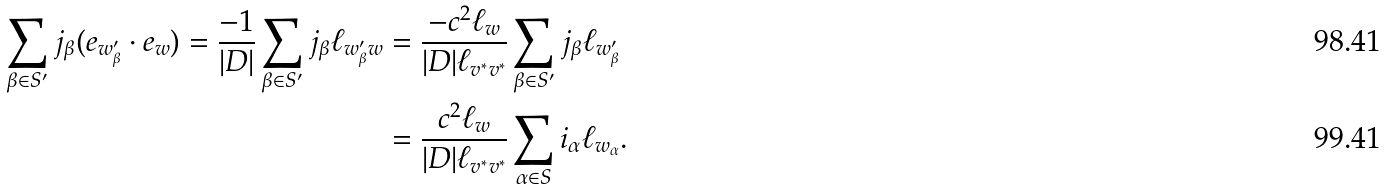<formula> <loc_0><loc_0><loc_500><loc_500>\sum _ { \beta \in S ^ { \prime } } j _ { \beta } ( e _ { w ^ { \prime } _ { \beta } } \cdot e _ { w } ) = \frac { - 1 } { | D | } \sum _ { \beta \in S ^ { \prime } } j _ { \beta } \ell _ { w ^ { \prime } _ { \beta } w } & = \frac { - c ^ { 2 } \ell _ { w } } { | D | \ell _ { v ^ { * } v ^ { * } } } \sum _ { \beta \in S ^ { \prime } } j _ { \beta } \ell _ { w ^ { \prime } _ { \beta } } \\ & = \frac { c ^ { 2 } \ell _ { w } } { | D | \ell _ { v ^ { * } v ^ { * } } } \sum _ { \alpha \in S } i _ { \alpha } \ell _ { w _ { \alpha } } .</formula> 